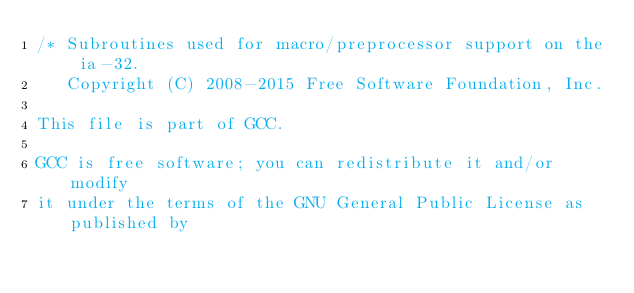<code> <loc_0><loc_0><loc_500><loc_500><_C_>/* Subroutines used for macro/preprocessor support on the ia-32.
   Copyright (C) 2008-2015 Free Software Foundation, Inc.

This file is part of GCC.

GCC is free software; you can redistribute it and/or modify
it under the terms of the GNU General Public License as published by</code> 